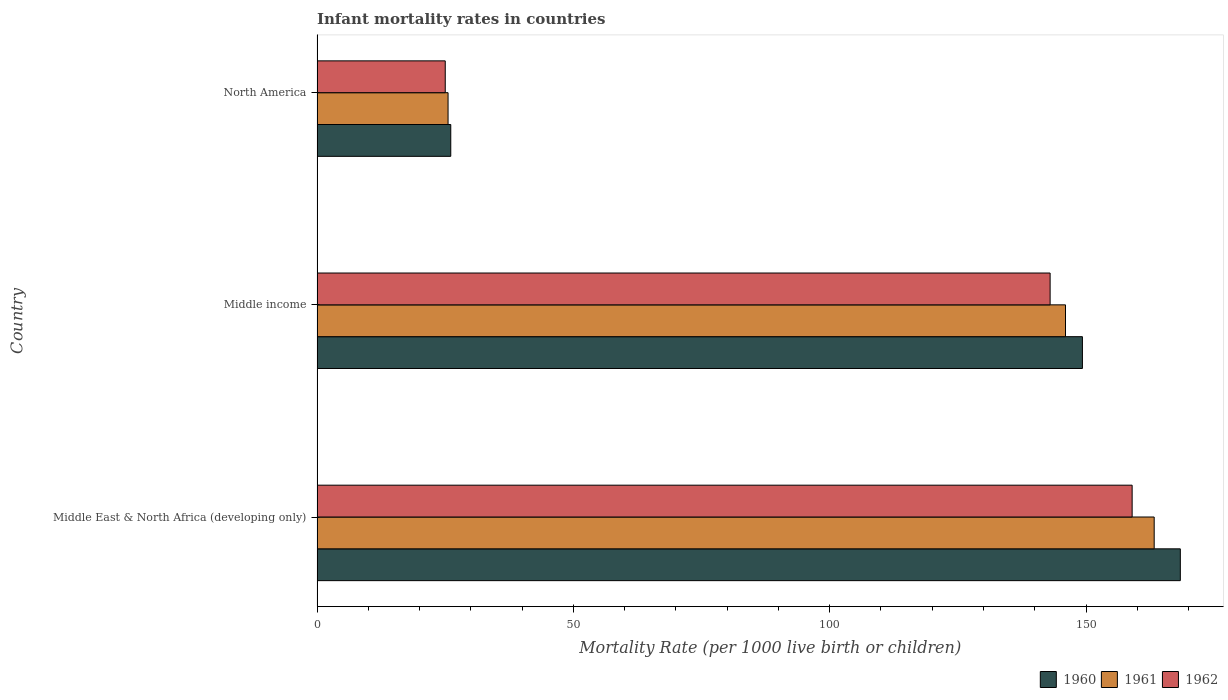How many groups of bars are there?
Your answer should be compact. 3. Are the number of bars per tick equal to the number of legend labels?
Offer a very short reply. Yes. How many bars are there on the 3rd tick from the bottom?
Offer a very short reply. 3. What is the infant mortality rate in 1960 in Middle income?
Ensure brevity in your answer.  149.3. Across all countries, what is the maximum infant mortality rate in 1962?
Your response must be concise. 159. Across all countries, what is the minimum infant mortality rate in 1960?
Your response must be concise. 26.08. In which country was the infant mortality rate in 1962 maximum?
Provide a short and direct response. Middle East & North Africa (developing only). What is the total infant mortality rate in 1960 in the graph?
Your response must be concise. 343.78. What is the difference between the infant mortality rate in 1962 in Middle East & North Africa (developing only) and that in Middle income?
Your answer should be very brief. 16. What is the difference between the infant mortality rate in 1962 in North America and the infant mortality rate in 1961 in Middle East & North Africa (developing only)?
Provide a short and direct response. -138.29. What is the average infant mortality rate in 1962 per country?
Your answer should be very brief. 109. What is the difference between the infant mortality rate in 1961 and infant mortality rate in 1960 in Middle income?
Ensure brevity in your answer.  -3.3. What is the ratio of the infant mortality rate in 1962 in Middle East & North Africa (developing only) to that in Middle income?
Make the answer very short. 1.11. Is the infant mortality rate in 1960 in Middle income less than that in North America?
Your response must be concise. No. What is the difference between the highest and the second highest infant mortality rate in 1961?
Make the answer very short. 17.3. What is the difference between the highest and the lowest infant mortality rate in 1960?
Keep it short and to the point. 142.32. In how many countries, is the infant mortality rate in 1960 greater than the average infant mortality rate in 1960 taken over all countries?
Ensure brevity in your answer.  2. Is it the case that in every country, the sum of the infant mortality rate in 1962 and infant mortality rate in 1961 is greater than the infant mortality rate in 1960?
Keep it short and to the point. Yes. How many countries are there in the graph?
Offer a terse response. 3. What is the difference between two consecutive major ticks on the X-axis?
Your answer should be very brief. 50. How many legend labels are there?
Offer a terse response. 3. How are the legend labels stacked?
Offer a terse response. Horizontal. What is the title of the graph?
Make the answer very short. Infant mortality rates in countries. What is the label or title of the X-axis?
Your answer should be very brief. Mortality Rate (per 1000 live birth or children). What is the Mortality Rate (per 1000 live birth or children) of 1960 in Middle East & North Africa (developing only)?
Give a very brief answer. 168.4. What is the Mortality Rate (per 1000 live birth or children) of 1961 in Middle East & North Africa (developing only)?
Your response must be concise. 163.3. What is the Mortality Rate (per 1000 live birth or children) in 1962 in Middle East & North Africa (developing only)?
Provide a succinct answer. 159. What is the Mortality Rate (per 1000 live birth or children) of 1960 in Middle income?
Offer a very short reply. 149.3. What is the Mortality Rate (per 1000 live birth or children) in 1961 in Middle income?
Keep it short and to the point. 146. What is the Mortality Rate (per 1000 live birth or children) of 1962 in Middle income?
Your response must be concise. 143. What is the Mortality Rate (per 1000 live birth or children) in 1960 in North America?
Offer a very short reply. 26.08. What is the Mortality Rate (per 1000 live birth or children) in 1961 in North America?
Your answer should be compact. 25.56. What is the Mortality Rate (per 1000 live birth or children) of 1962 in North America?
Ensure brevity in your answer.  25.01. Across all countries, what is the maximum Mortality Rate (per 1000 live birth or children) in 1960?
Give a very brief answer. 168.4. Across all countries, what is the maximum Mortality Rate (per 1000 live birth or children) in 1961?
Your answer should be very brief. 163.3. Across all countries, what is the maximum Mortality Rate (per 1000 live birth or children) of 1962?
Provide a short and direct response. 159. Across all countries, what is the minimum Mortality Rate (per 1000 live birth or children) in 1960?
Provide a short and direct response. 26.08. Across all countries, what is the minimum Mortality Rate (per 1000 live birth or children) of 1961?
Offer a very short reply. 25.56. Across all countries, what is the minimum Mortality Rate (per 1000 live birth or children) in 1962?
Give a very brief answer. 25.01. What is the total Mortality Rate (per 1000 live birth or children) of 1960 in the graph?
Provide a succinct answer. 343.78. What is the total Mortality Rate (per 1000 live birth or children) in 1961 in the graph?
Offer a terse response. 334.86. What is the total Mortality Rate (per 1000 live birth or children) of 1962 in the graph?
Your answer should be very brief. 327.01. What is the difference between the Mortality Rate (per 1000 live birth or children) in 1961 in Middle East & North Africa (developing only) and that in Middle income?
Provide a succinct answer. 17.3. What is the difference between the Mortality Rate (per 1000 live birth or children) in 1960 in Middle East & North Africa (developing only) and that in North America?
Ensure brevity in your answer.  142.32. What is the difference between the Mortality Rate (per 1000 live birth or children) in 1961 in Middle East & North Africa (developing only) and that in North America?
Offer a very short reply. 137.74. What is the difference between the Mortality Rate (per 1000 live birth or children) of 1962 in Middle East & North Africa (developing only) and that in North America?
Offer a terse response. 133.99. What is the difference between the Mortality Rate (per 1000 live birth or children) in 1960 in Middle income and that in North America?
Keep it short and to the point. 123.22. What is the difference between the Mortality Rate (per 1000 live birth or children) of 1961 in Middle income and that in North America?
Offer a terse response. 120.44. What is the difference between the Mortality Rate (per 1000 live birth or children) in 1962 in Middle income and that in North America?
Give a very brief answer. 117.99. What is the difference between the Mortality Rate (per 1000 live birth or children) in 1960 in Middle East & North Africa (developing only) and the Mortality Rate (per 1000 live birth or children) in 1961 in Middle income?
Your response must be concise. 22.4. What is the difference between the Mortality Rate (per 1000 live birth or children) in 1960 in Middle East & North Africa (developing only) and the Mortality Rate (per 1000 live birth or children) in 1962 in Middle income?
Provide a succinct answer. 25.4. What is the difference between the Mortality Rate (per 1000 live birth or children) in 1961 in Middle East & North Africa (developing only) and the Mortality Rate (per 1000 live birth or children) in 1962 in Middle income?
Offer a very short reply. 20.3. What is the difference between the Mortality Rate (per 1000 live birth or children) of 1960 in Middle East & North Africa (developing only) and the Mortality Rate (per 1000 live birth or children) of 1961 in North America?
Your answer should be very brief. 142.84. What is the difference between the Mortality Rate (per 1000 live birth or children) in 1960 in Middle East & North Africa (developing only) and the Mortality Rate (per 1000 live birth or children) in 1962 in North America?
Give a very brief answer. 143.39. What is the difference between the Mortality Rate (per 1000 live birth or children) in 1961 in Middle East & North Africa (developing only) and the Mortality Rate (per 1000 live birth or children) in 1962 in North America?
Give a very brief answer. 138.29. What is the difference between the Mortality Rate (per 1000 live birth or children) in 1960 in Middle income and the Mortality Rate (per 1000 live birth or children) in 1961 in North America?
Offer a very short reply. 123.74. What is the difference between the Mortality Rate (per 1000 live birth or children) of 1960 in Middle income and the Mortality Rate (per 1000 live birth or children) of 1962 in North America?
Offer a very short reply. 124.29. What is the difference between the Mortality Rate (per 1000 live birth or children) in 1961 in Middle income and the Mortality Rate (per 1000 live birth or children) in 1962 in North America?
Your response must be concise. 120.99. What is the average Mortality Rate (per 1000 live birth or children) of 1960 per country?
Your answer should be compact. 114.59. What is the average Mortality Rate (per 1000 live birth or children) of 1961 per country?
Keep it short and to the point. 111.62. What is the average Mortality Rate (per 1000 live birth or children) of 1962 per country?
Make the answer very short. 109. What is the difference between the Mortality Rate (per 1000 live birth or children) in 1960 and Mortality Rate (per 1000 live birth or children) in 1962 in Middle East & North Africa (developing only)?
Give a very brief answer. 9.4. What is the difference between the Mortality Rate (per 1000 live birth or children) of 1961 and Mortality Rate (per 1000 live birth or children) of 1962 in Middle income?
Your answer should be compact. 3. What is the difference between the Mortality Rate (per 1000 live birth or children) in 1960 and Mortality Rate (per 1000 live birth or children) in 1961 in North America?
Provide a short and direct response. 0.53. What is the difference between the Mortality Rate (per 1000 live birth or children) of 1960 and Mortality Rate (per 1000 live birth or children) of 1962 in North America?
Offer a very short reply. 1.08. What is the difference between the Mortality Rate (per 1000 live birth or children) in 1961 and Mortality Rate (per 1000 live birth or children) in 1962 in North America?
Your answer should be compact. 0.55. What is the ratio of the Mortality Rate (per 1000 live birth or children) of 1960 in Middle East & North Africa (developing only) to that in Middle income?
Ensure brevity in your answer.  1.13. What is the ratio of the Mortality Rate (per 1000 live birth or children) in 1961 in Middle East & North Africa (developing only) to that in Middle income?
Your answer should be compact. 1.12. What is the ratio of the Mortality Rate (per 1000 live birth or children) in 1962 in Middle East & North Africa (developing only) to that in Middle income?
Your answer should be very brief. 1.11. What is the ratio of the Mortality Rate (per 1000 live birth or children) in 1960 in Middle East & North Africa (developing only) to that in North America?
Ensure brevity in your answer.  6.46. What is the ratio of the Mortality Rate (per 1000 live birth or children) of 1961 in Middle East & North Africa (developing only) to that in North America?
Your answer should be very brief. 6.39. What is the ratio of the Mortality Rate (per 1000 live birth or children) of 1962 in Middle East & North Africa (developing only) to that in North America?
Provide a short and direct response. 6.36. What is the ratio of the Mortality Rate (per 1000 live birth or children) in 1960 in Middle income to that in North America?
Offer a very short reply. 5.72. What is the ratio of the Mortality Rate (per 1000 live birth or children) in 1961 in Middle income to that in North America?
Offer a terse response. 5.71. What is the ratio of the Mortality Rate (per 1000 live birth or children) in 1962 in Middle income to that in North America?
Your answer should be very brief. 5.72. What is the difference between the highest and the lowest Mortality Rate (per 1000 live birth or children) of 1960?
Your answer should be very brief. 142.32. What is the difference between the highest and the lowest Mortality Rate (per 1000 live birth or children) of 1961?
Keep it short and to the point. 137.74. What is the difference between the highest and the lowest Mortality Rate (per 1000 live birth or children) of 1962?
Your answer should be very brief. 133.99. 